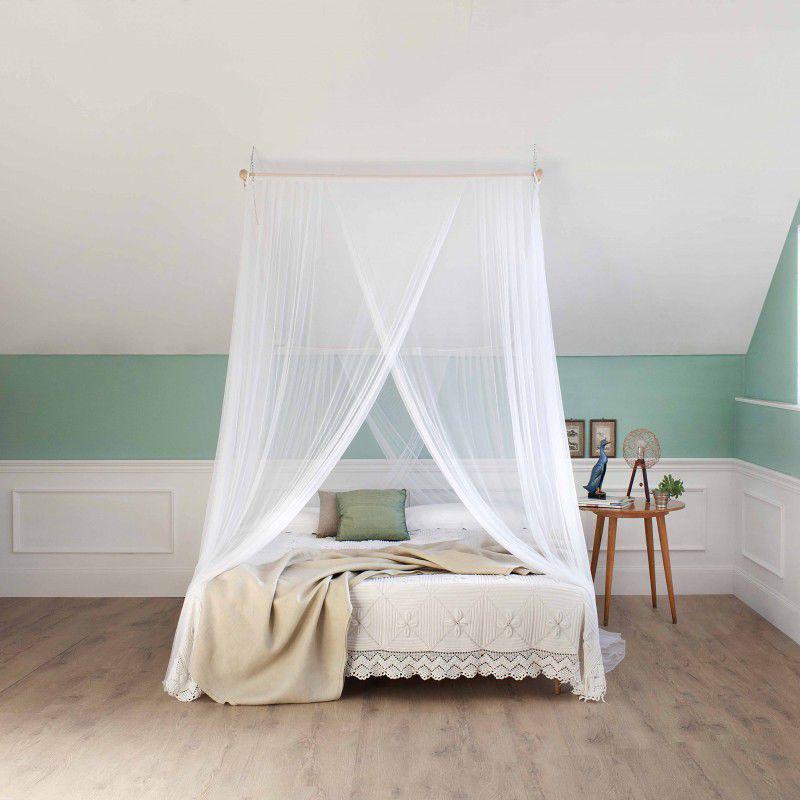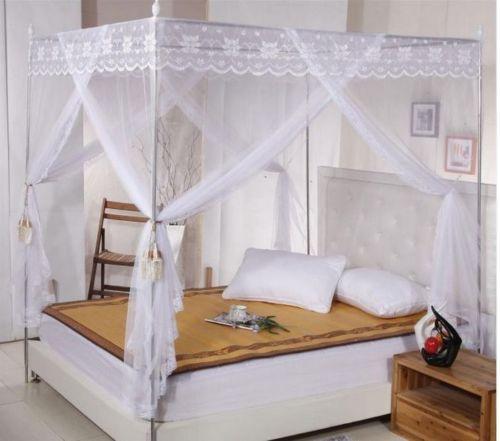The first image is the image on the left, the second image is the image on the right. Analyze the images presented: Is the assertion "There are two white square canopies." valid? Answer yes or no. Yes. The first image is the image on the left, the second image is the image on the right. Assess this claim about the two images: "Exactly one bed net is attached to the ceiling.". Correct or not? Answer yes or no. Yes. 